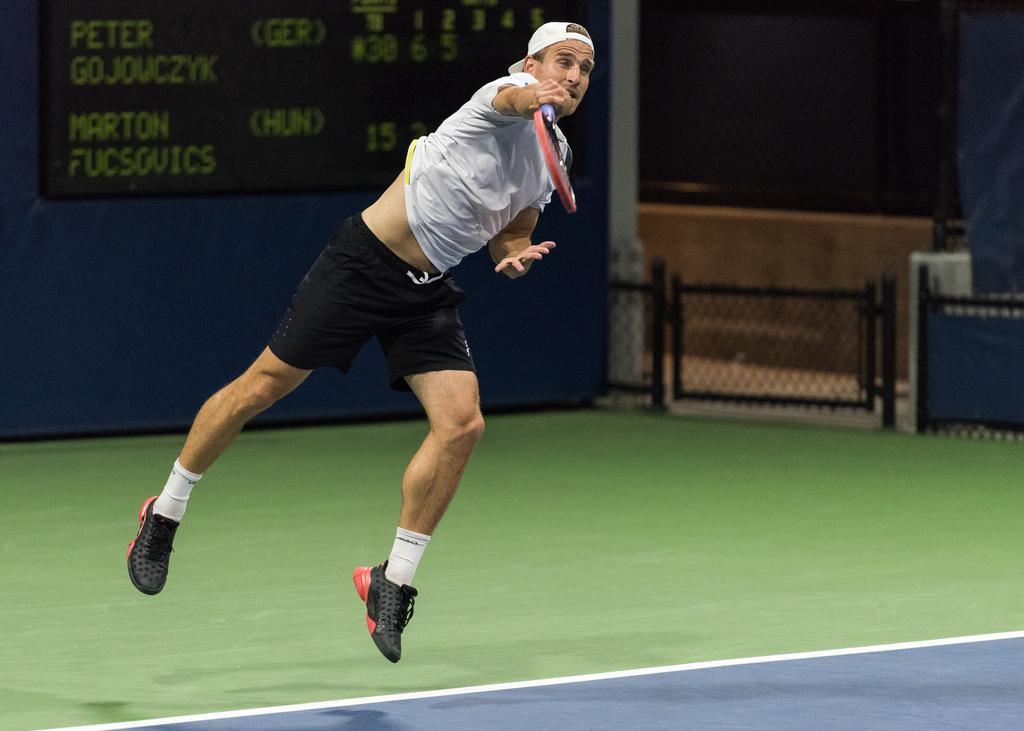Can you describe this image briefly? Here is a man jumping and playing tennis,holding the tennis racket. Here I can see the scoreboard at the background. This looks like a small gate. 